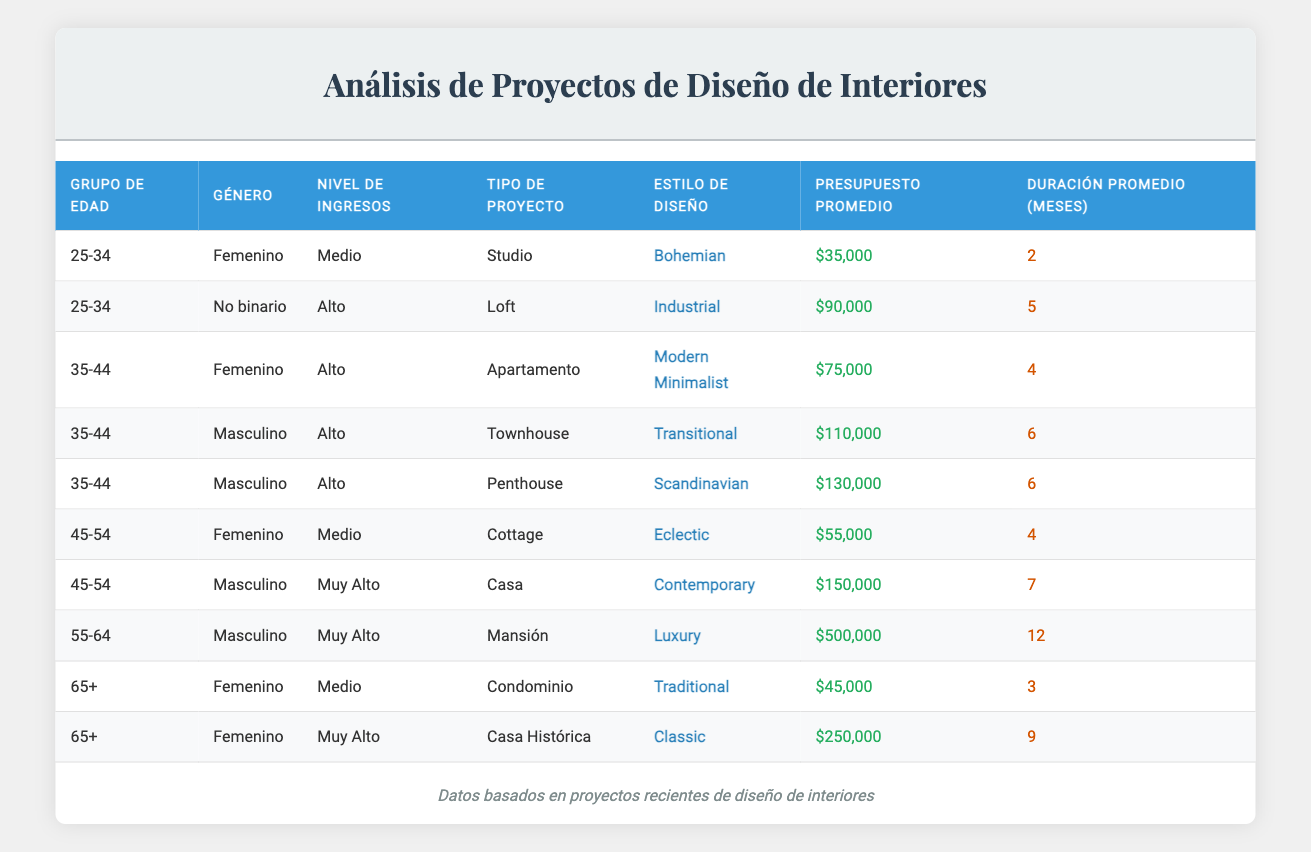What design style is chosen most frequently by male clients aged 35-44? There are three male clients in the age group 35-44: one chose Transitional for a Townhouse, and another chose Scandinavian for a Penthouse. The other male client was categorized in a different age group. Therefore, we can't determine a predominant design style for this specific age and gender combination.
Answer: None What is the highest average budget for a design project based on the income bracket? The highest income bracket is "Very High," which has two projects: one for a Mansion with a budget of $500,000 and one for a Historic Home with a budget of $250,000. The average is calculated as (500000 + 250000) / 2 = 375000.
Answer: $375,000 How many different design styles are represented for clients aged 45-54? There are two clients in this age group: one has an Eclectic style for a Cottage and the other has a Contemporary style for a House. Thus, there are two different design styles.
Answer: 2 What is the average project duration for apartments and townhouses combined? The apartment project has a duration of 4 months, and the townhouse project has a duration of 6 months. The average is calculated as (4 + 6) / 2 = 5.
Answer: 5 months Is there any female client with a budget over $100,000? Two female clients are present, one with a budget of $250,000 for a Classic design and another with a budget of $45,000 for Traditional. Therefore, yes, there is a female client with a budget over $100,000.
Answer: Yes What design style corresponds to the highest project budget among clients aged 65 and older? For clients aged 65 and older, there are two styles listed: Traditional with a budget of $45,000 and Classic with a budget of $250,000. The Classic design style has the highest budget of the two.
Answer: Classic What is the overall average budget for projects involving female clients? The budgets for female clients are $75,000, $35,000, $55,000, and $250,000. The total budget is 75,000 + 35,000 + 55,000 + 250,000 = 415,000, and dividing by 4 yields an average of 415,000 / 4 = $103,750.
Answer: $103,750 What project type is most commonly associated with middle-income clients? There is one Middle-income client associated with a condo project lasting 3 months and with a Traditional design style. Hence, the only project type associated with middle-income clients is the condo.
Answer: Condo 